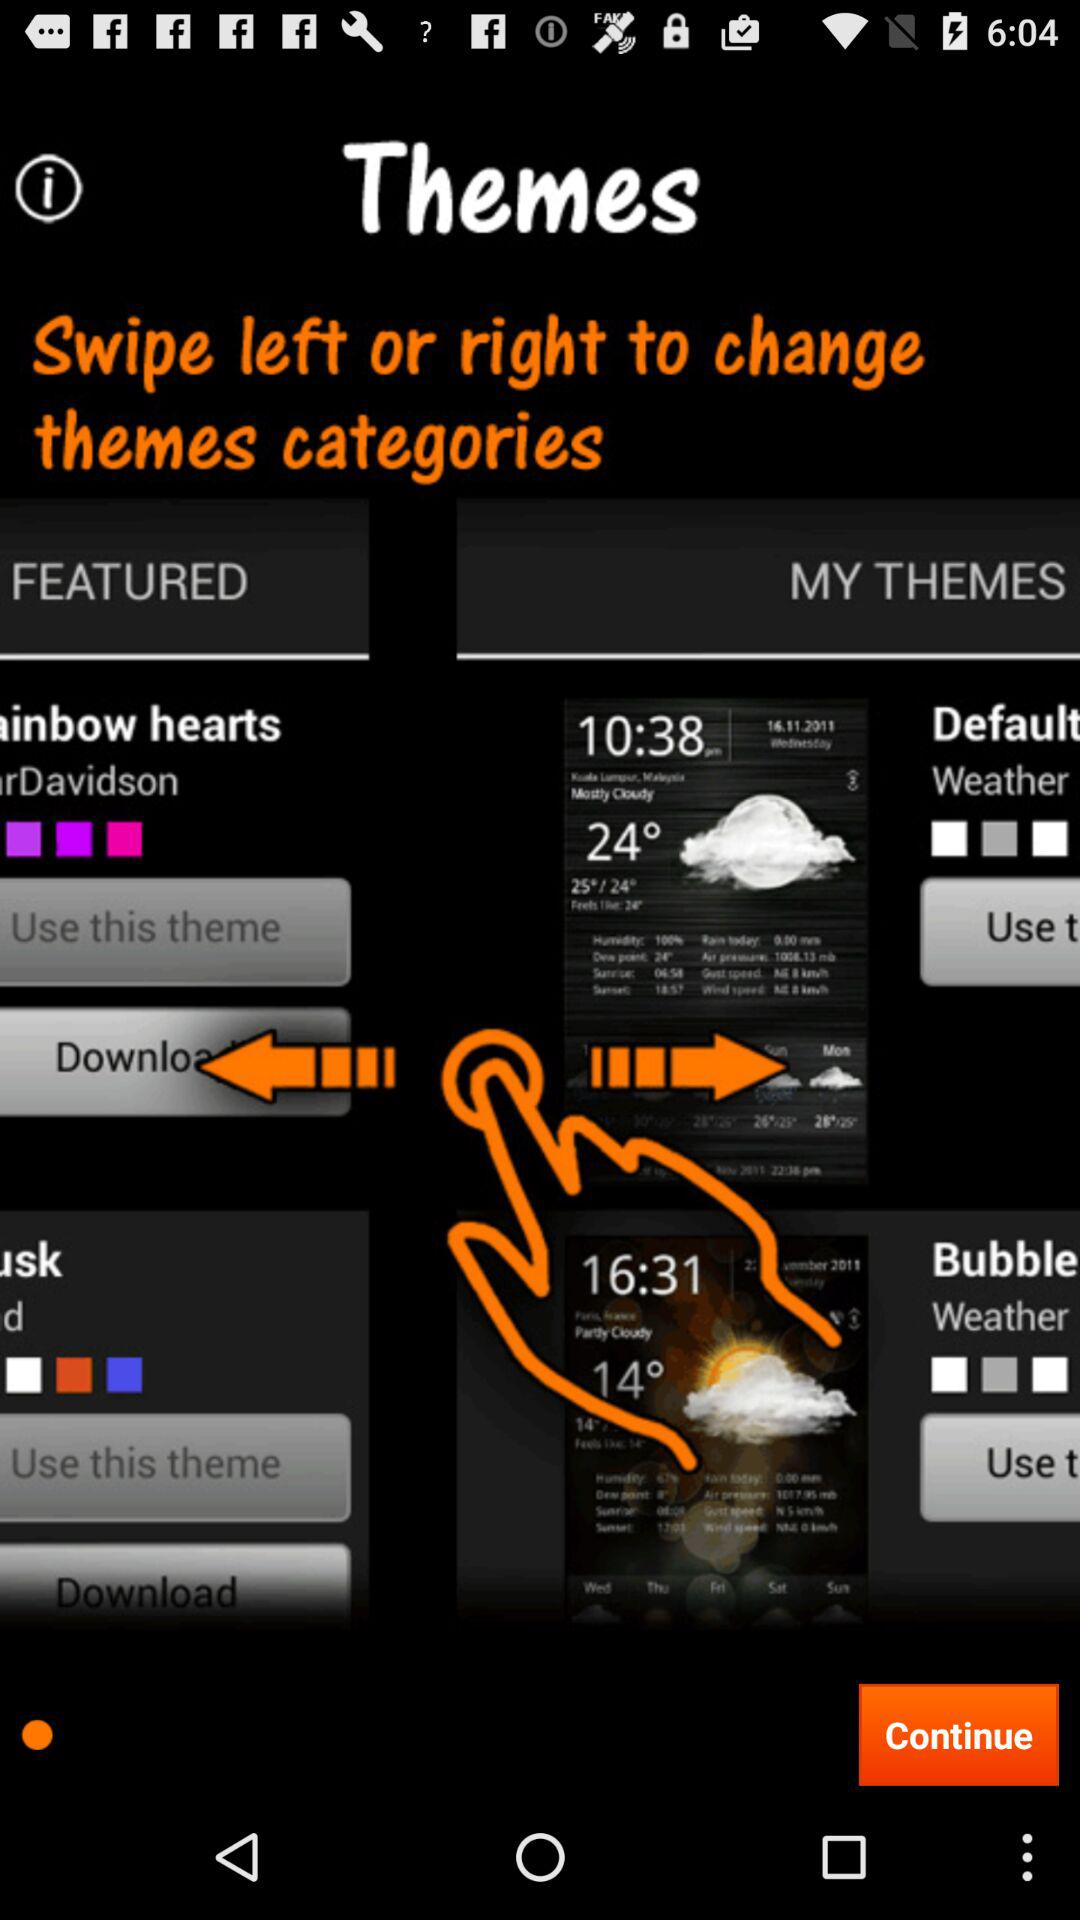How is the weather on 14.11.2011?
When the provided information is insufficient, respond with <no answer>. <no answer> 